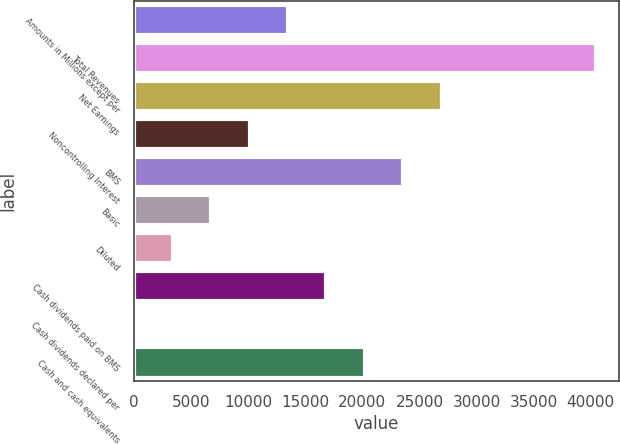Convert chart to OTSL. <chart><loc_0><loc_0><loc_500><loc_500><bar_chart><fcel>Amounts in Millions except per<fcel>Total Revenues<fcel>Net Earnings<fcel>Noncontrolling Interest<fcel>BMS<fcel>Basic<fcel>Diluted<fcel>Cash dividends paid on BMS<fcel>Cash dividends declared per<fcel>Cash and cash equivalents<nl><fcel>13483.7<fcel>40448.1<fcel>26965.9<fcel>10113.2<fcel>23595.4<fcel>6742.63<fcel>3372.08<fcel>16854.3<fcel>1.53<fcel>20224.8<nl></chart> 